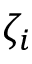<formula> <loc_0><loc_0><loc_500><loc_500>\zeta _ { i }</formula> 